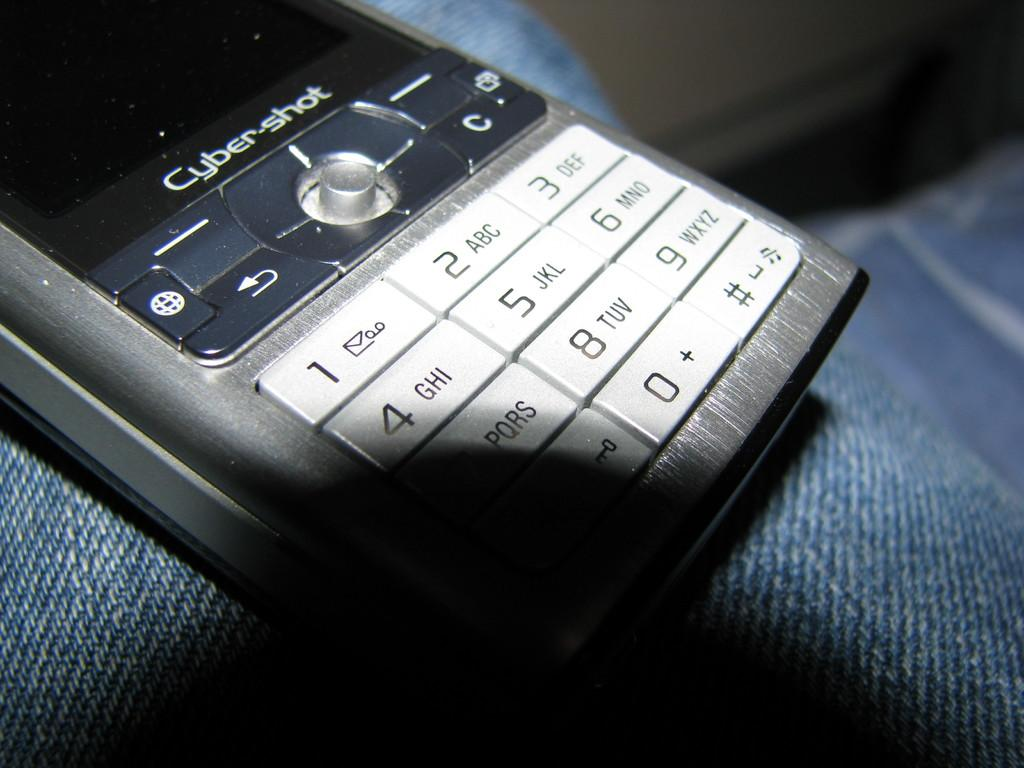<image>
Relay a brief, clear account of the picture shown. A cell phone made by Cyber shot is sitting on someone's jeans. 